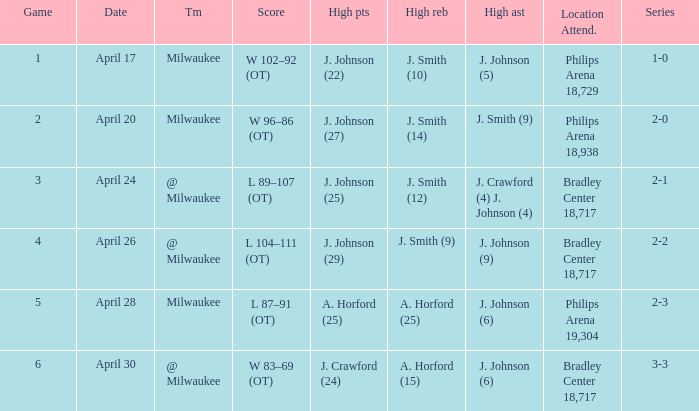What were the amount of rebounds in game 2? J. Smith (14). Parse the table in full. {'header': ['Game', 'Date', 'Tm', 'Score', 'High pts', 'High reb', 'High ast', 'Location Attend.', 'Series'], 'rows': [['1', 'April 17', 'Milwaukee', 'W 102–92 (OT)', 'J. Johnson (22)', 'J. Smith (10)', 'J. Johnson (5)', 'Philips Arena 18,729', '1-0'], ['2', 'April 20', 'Milwaukee', 'W 96–86 (OT)', 'J. Johnson (27)', 'J. Smith (14)', 'J. Smith (9)', 'Philips Arena 18,938', '2-0'], ['3', 'April 24', '@ Milwaukee', 'L 89–107 (OT)', 'J. Johnson (25)', 'J. Smith (12)', 'J. Crawford (4) J. Johnson (4)', 'Bradley Center 18,717', '2-1'], ['4', 'April 26', '@ Milwaukee', 'L 104–111 (OT)', 'J. Johnson (29)', 'J. Smith (9)', 'J. Johnson (9)', 'Bradley Center 18,717', '2-2'], ['5', 'April 28', 'Milwaukee', 'L 87–91 (OT)', 'A. Horford (25)', 'A. Horford (25)', 'J. Johnson (6)', 'Philips Arena 19,304', '2-3'], ['6', 'April 30', '@ Milwaukee', 'W 83–69 (OT)', 'J. Crawford (24)', 'A. Horford (15)', 'J. Johnson (6)', 'Bradley Center 18,717', '3-3']]} 